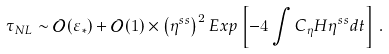Convert formula to latex. <formula><loc_0><loc_0><loc_500><loc_500>\tau _ { N L } & \sim \mathcal { O } ( \varepsilon _ { * } ) + \mathcal { O } ( 1 ) \times \left ( \eta ^ { s s } \right ) ^ { 2 } E x p \left [ - 4 \int C _ { \eta } H \eta ^ { s s } d t \right ] \, .</formula> 